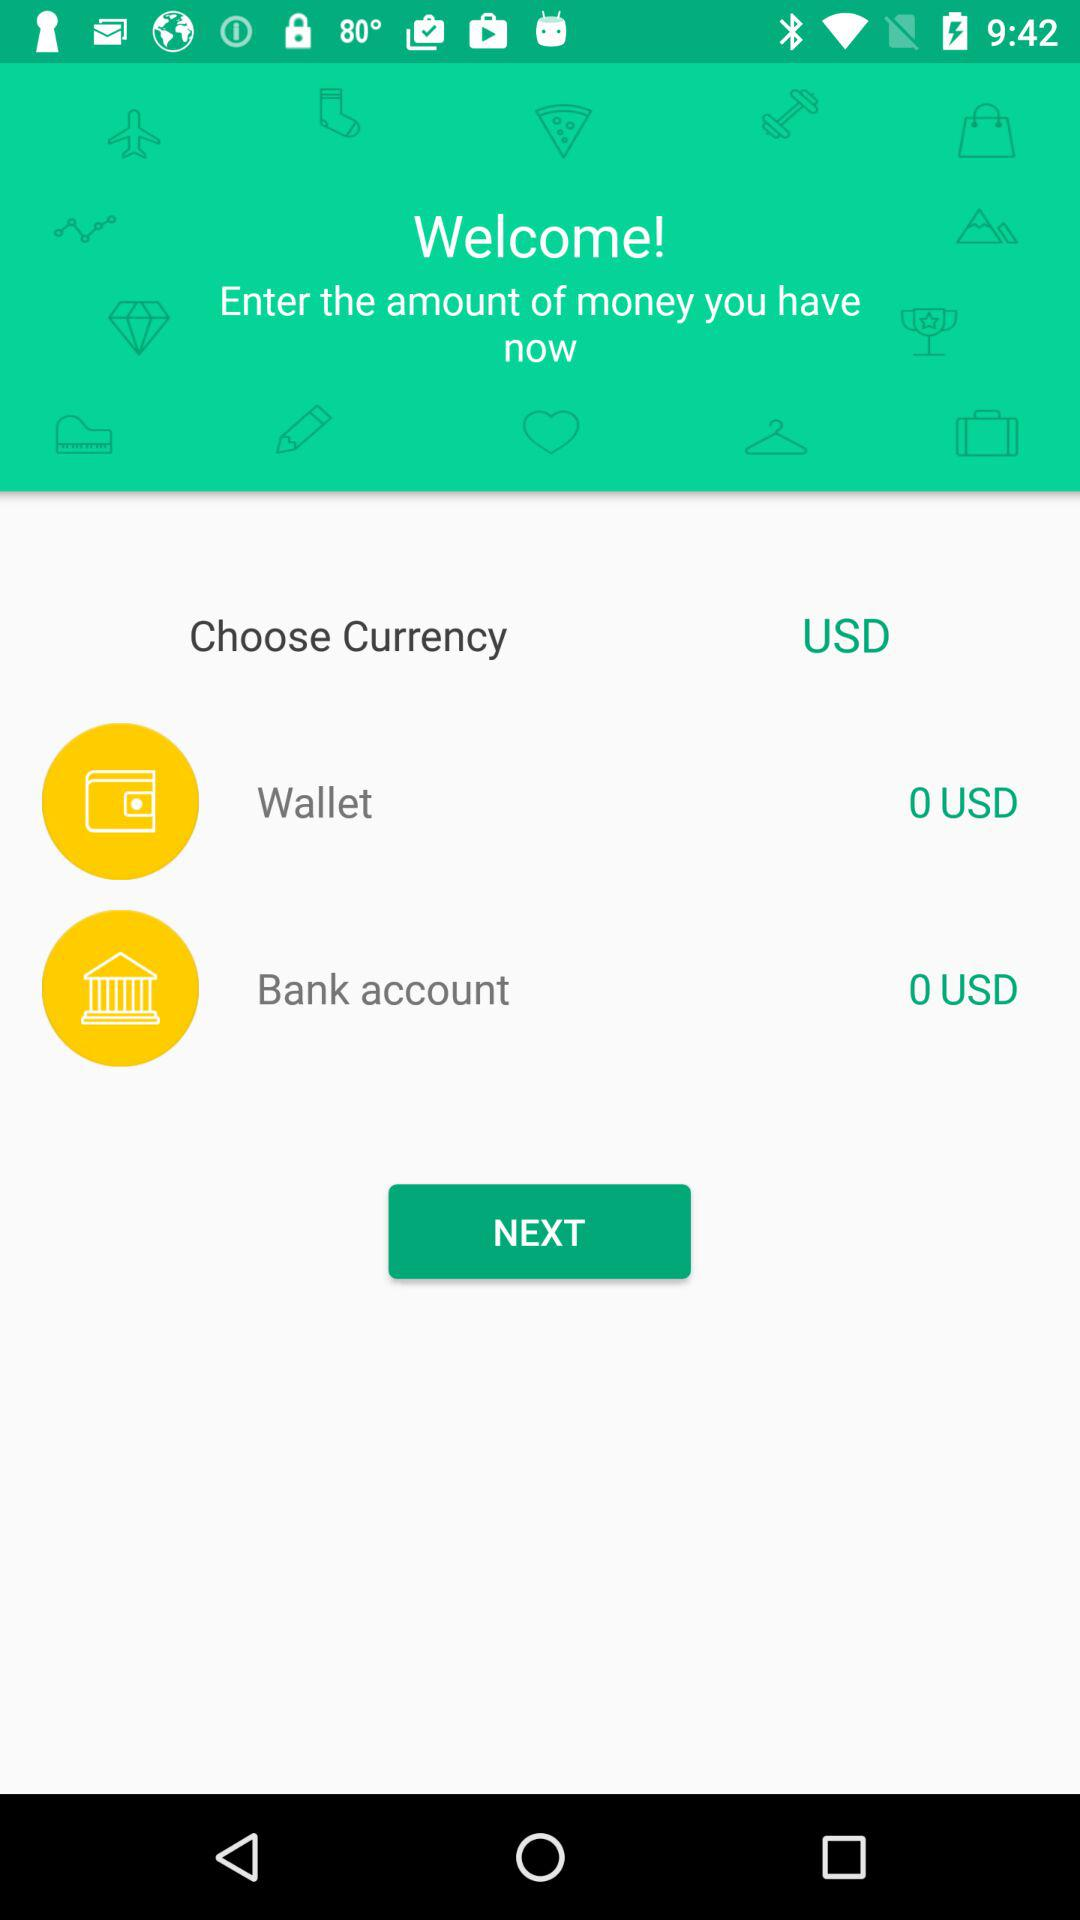How much money is in the bank account? There is 0 USD in the bank account. 